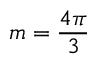Convert formula to latex. <formula><loc_0><loc_0><loc_500><loc_500>m = { \frac { 4 \pi } { 3 } }</formula> 